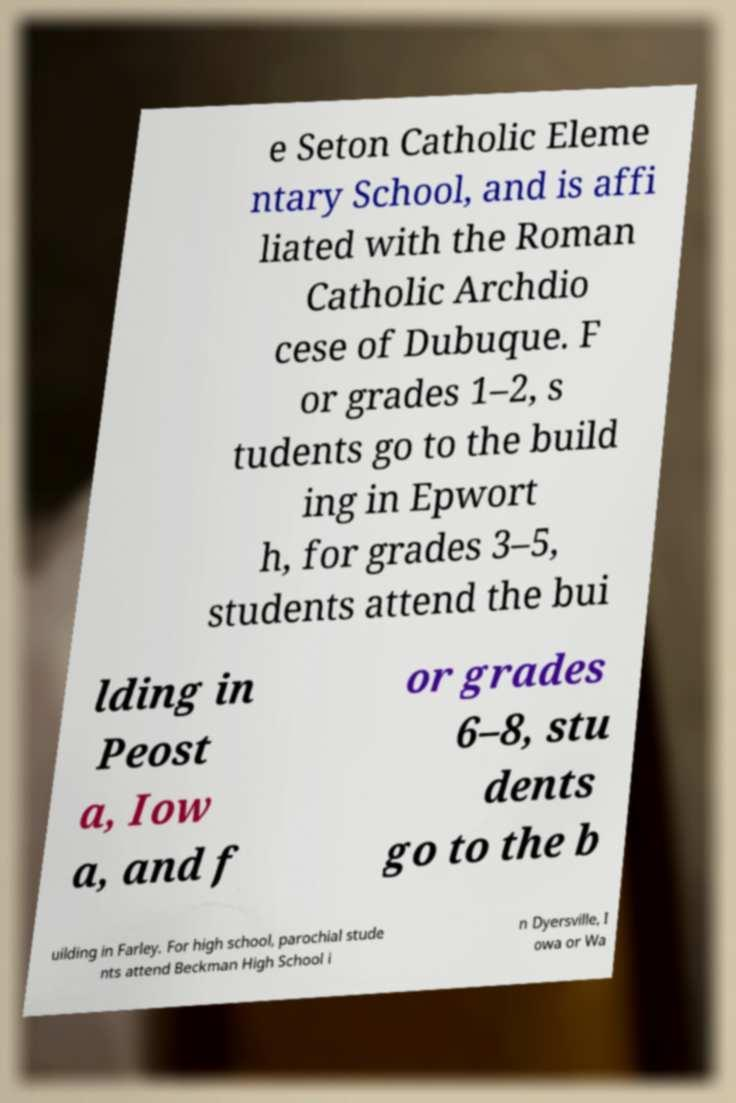There's text embedded in this image that I need extracted. Can you transcribe it verbatim? e Seton Catholic Eleme ntary School, and is affi liated with the Roman Catholic Archdio cese of Dubuque. F or grades 1–2, s tudents go to the build ing in Epwort h, for grades 3–5, students attend the bui lding in Peost a, Iow a, and f or grades 6–8, stu dents go to the b uilding in Farley. For high school, parochial stude nts attend Beckman High School i n Dyersville, I owa or Wa 